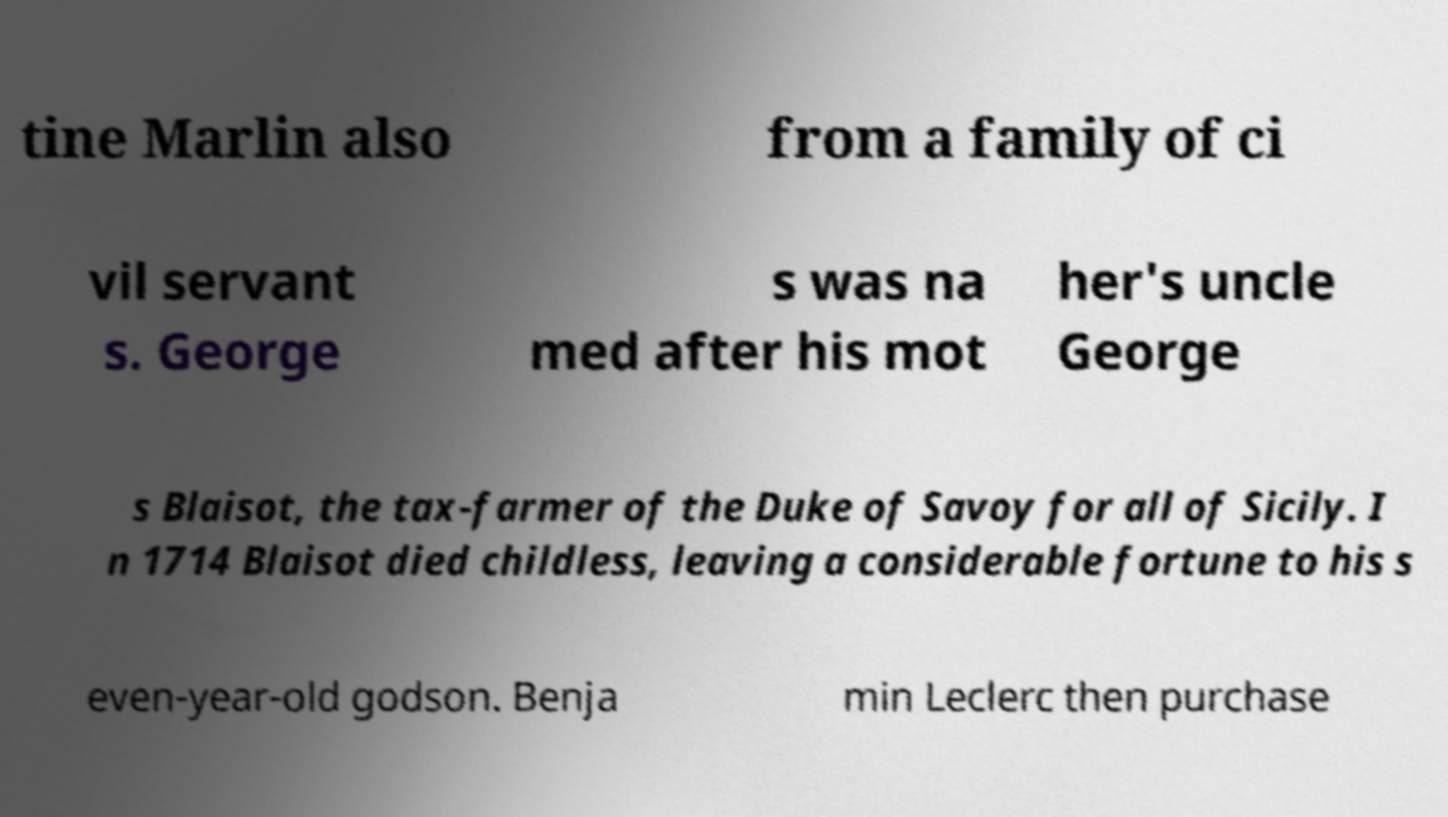Can you read and provide the text displayed in the image?This photo seems to have some interesting text. Can you extract and type it out for me? tine Marlin also from a family of ci vil servant s. George s was na med after his mot her's uncle George s Blaisot, the tax-farmer of the Duke of Savoy for all of Sicily. I n 1714 Blaisot died childless, leaving a considerable fortune to his s even-year-old godson. Benja min Leclerc then purchase 